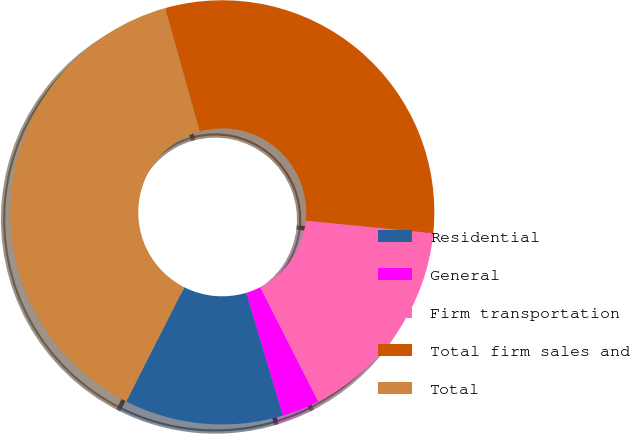<chart> <loc_0><loc_0><loc_500><loc_500><pie_chart><fcel>Residential<fcel>General<fcel>Firm transportation<fcel>Total firm sales and<fcel>Total<nl><fcel>12.1%<fcel>2.85%<fcel>15.96%<fcel>30.91%<fcel>38.19%<nl></chart> 